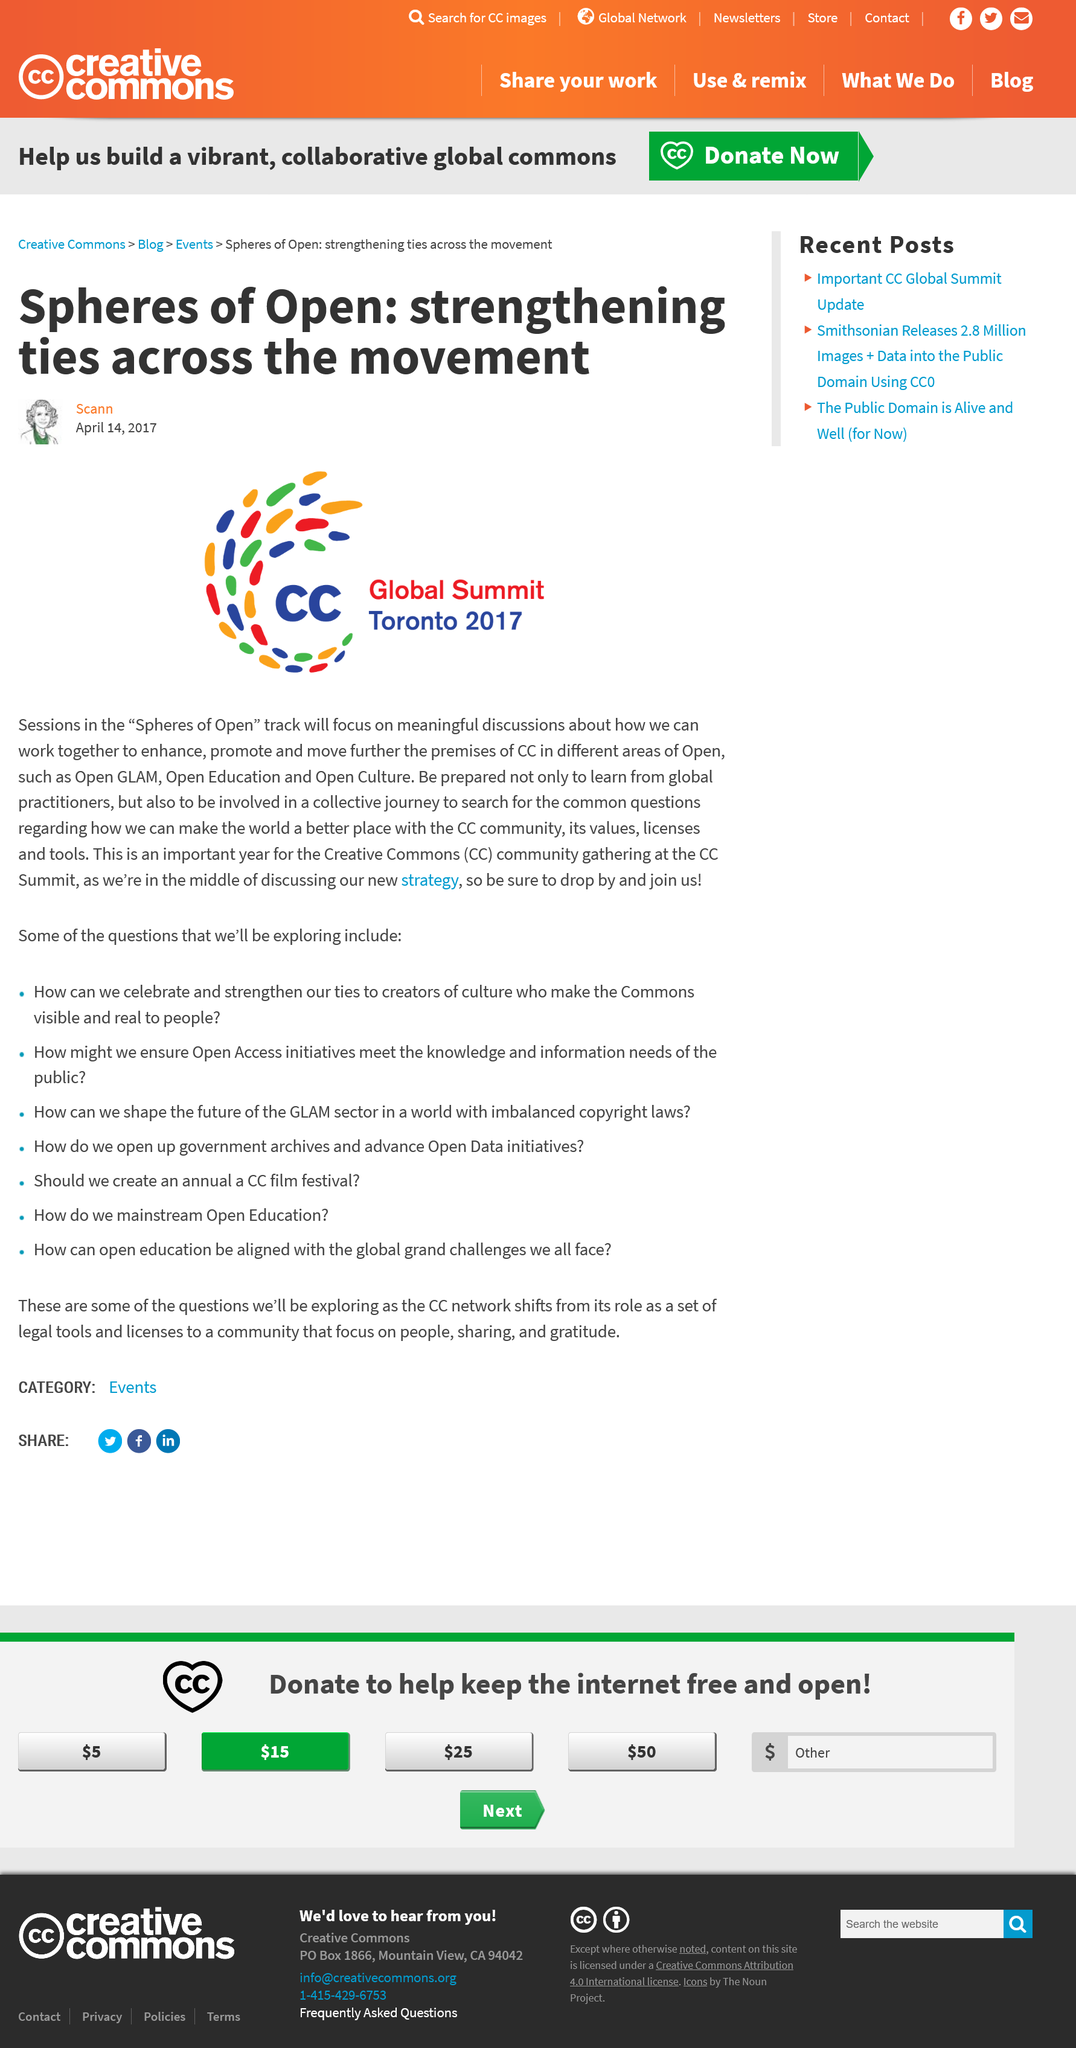Outline some significant characteristics in this image. The Global Summit will occur on April 14, 2017. The "Spheres of Open" track sessions aim to facilitate meaningful discussions on collaborative efforts to advance and strengthen the principles of Community-Centeredness (CC) in various aspects of Open, including Open GLAM, Open Education, and Open Culture. The CC Global Summit is being held in Toronto. 